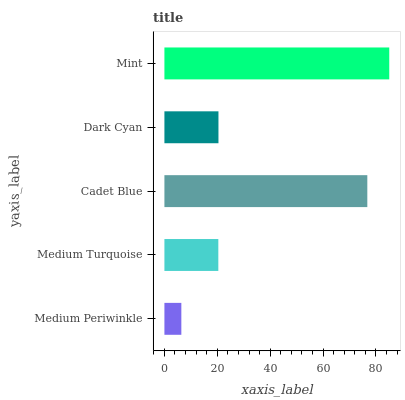Is Medium Periwinkle the minimum?
Answer yes or no. Yes. Is Mint the maximum?
Answer yes or no. Yes. Is Medium Turquoise the minimum?
Answer yes or no. No. Is Medium Turquoise the maximum?
Answer yes or no. No. Is Medium Turquoise greater than Medium Periwinkle?
Answer yes or no. Yes. Is Medium Periwinkle less than Medium Turquoise?
Answer yes or no. Yes. Is Medium Periwinkle greater than Medium Turquoise?
Answer yes or no. No. Is Medium Turquoise less than Medium Periwinkle?
Answer yes or no. No. Is Dark Cyan the high median?
Answer yes or no. Yes. Is Dark Cyan the low median?
Answer yes or no. Yes. Is Medium Turquoise the high median?
Answer yes or no. No. Is Cadet Blue the low median?
Answer yes or no. No. 